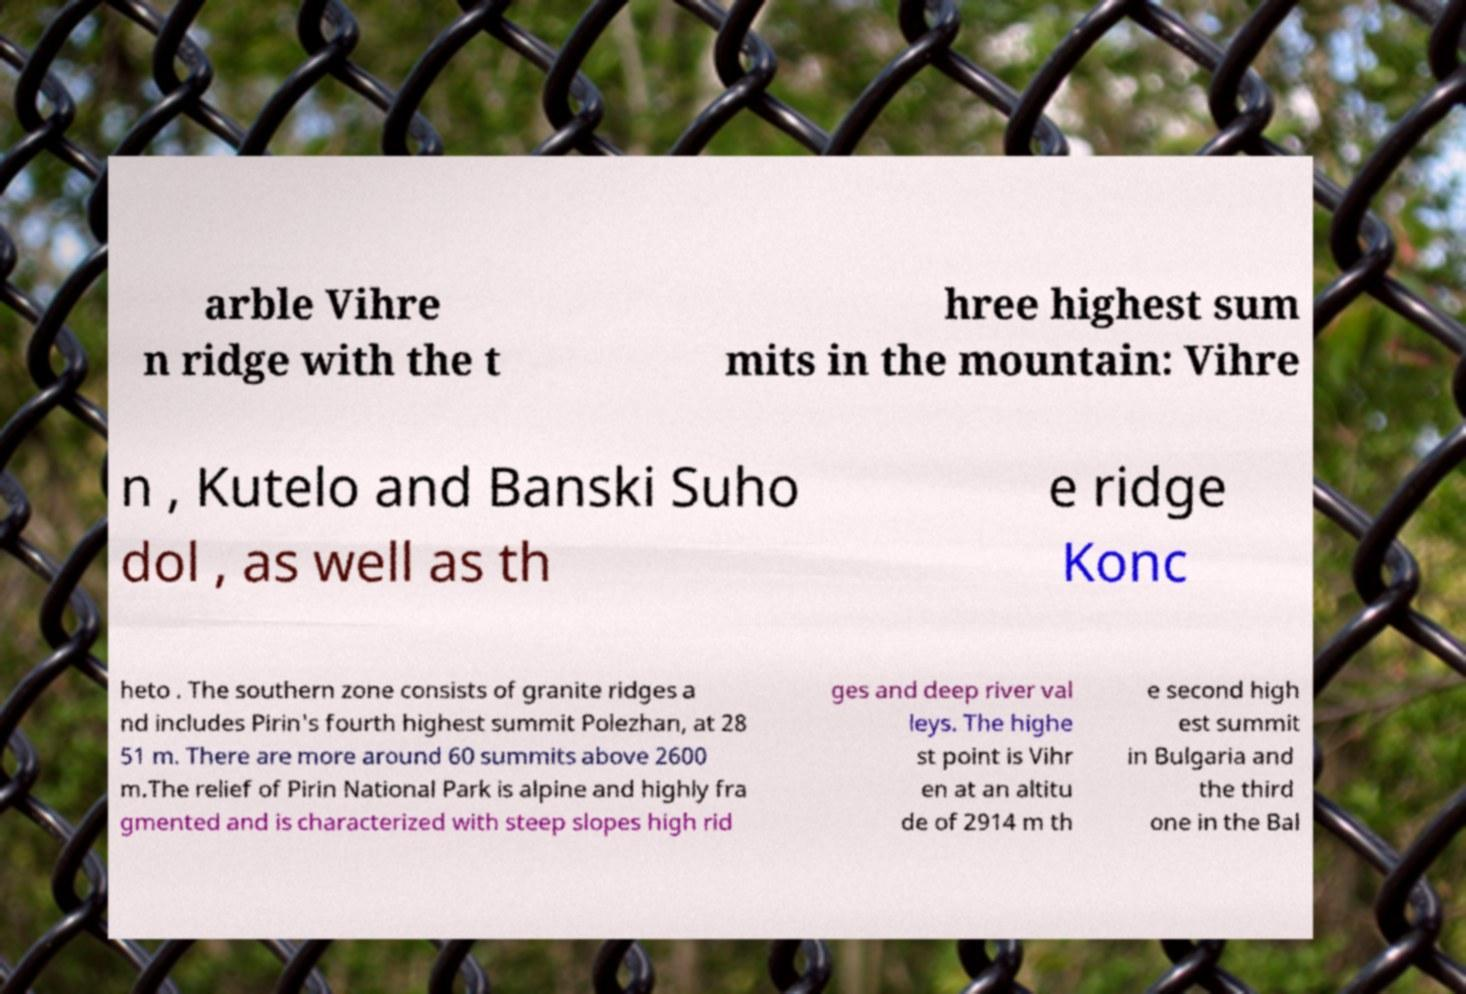Please identify and transcribe the text found in this image. arble Vihre n ridge with the t hree highest sum mits in the mountain: Vihre n , Kutelo and Banski Suho dol , as well as th e ridge Konc heto . The southern zone consists of granite ridges a nd includes Pirin's fourth highest summit Polezhan, at 28 51 m. There are more around 60 summits above 2600 m.The relief of Pirin National Park is alpine and highly fra gmented and is characterized with steep slopes high rid ges and deep river val leys. The highe st point is Vihr en at an altitu de of 2914 m th e second high est summit in Bulgaria and the third one in the Bal 